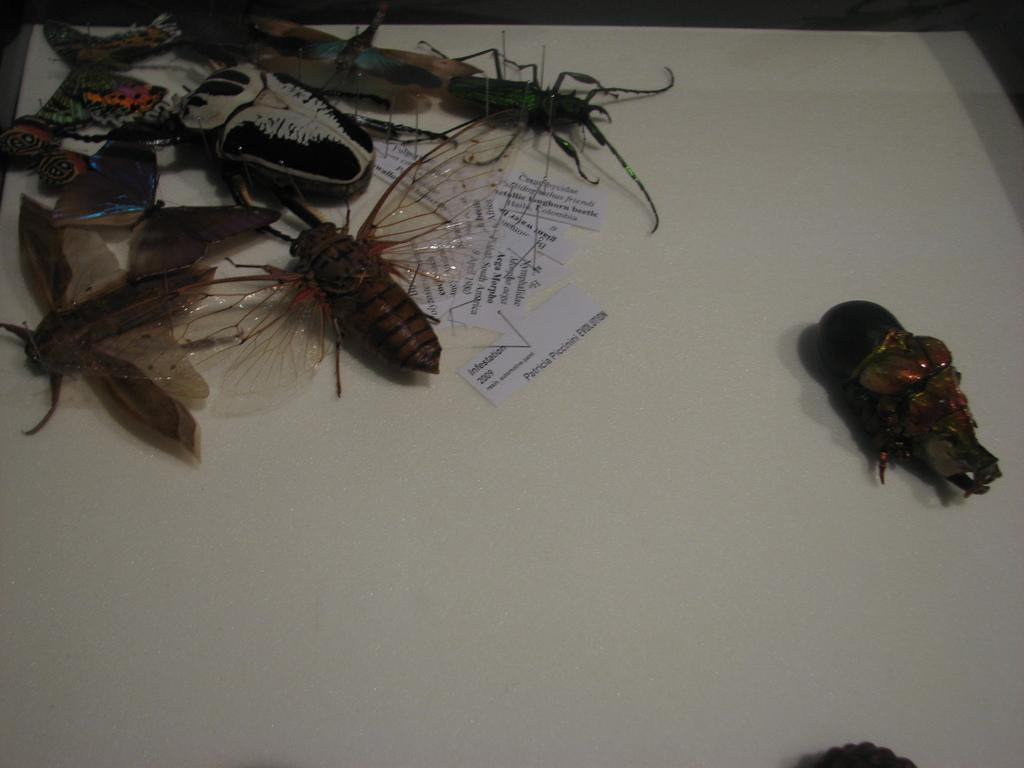What type of insects are present in the image? There are cockroaches and butterflies in the image. What type of paper is visible in the image? There are text papers in the image. What is the color of the surface in the image? The surface in the image is white. What type of duck can be seen singing songs in the image? There is no duck present in the image, and no one is singing songs. 